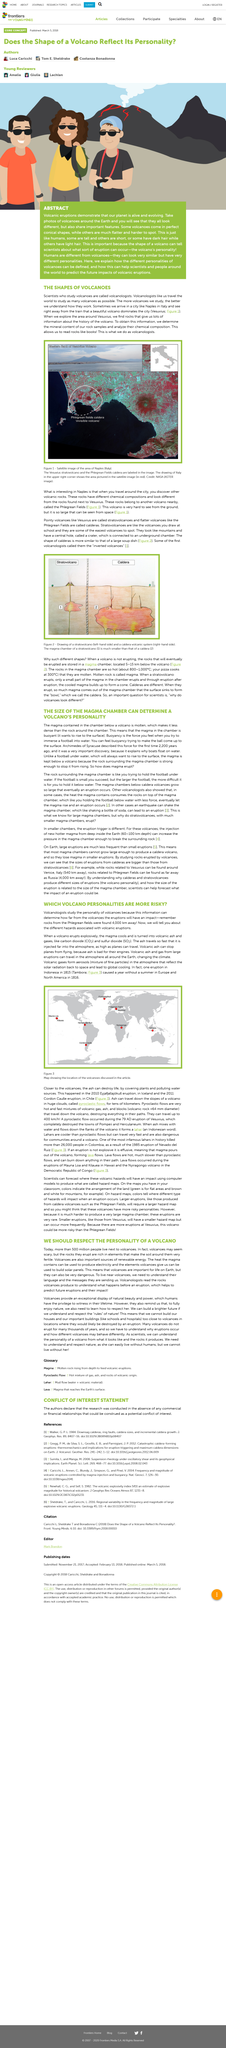Indicate a few pertinent items in this graphic. The satellite image of the "invisible volcano" is revealing the region of Naples. The injection of new, hotter magma into smaller chambers in the Earth's mantle must occur from a depth of approximately 60-100 kilometers, which is located deep within the Earth's interior. The magma in the chamber below a volcano is buoyant because it is molten, making it less dense than the rock around the chamber, resulting in it rising to the surface. During the process of volcanic eruption, when magma cools, it transforms into volcanic ash and gases, such as carbon dioxide (CO2) and sulfur dioxide (SO2). Figure 1 displays not only the invisible volcano but also the Vesuvius volcano, which is visible and well-known. 